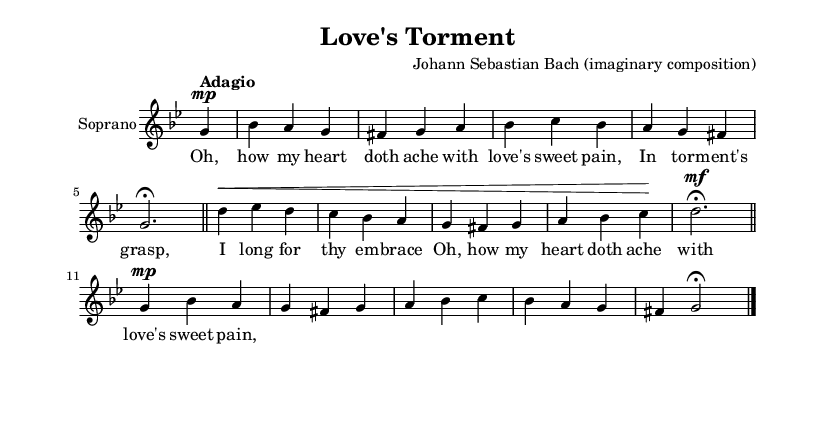What is the key signature of this music? The key signature is indicated at the beginning of the staff. The presence of two flats shows that it is in G minor.
Answer: G minor What is the time signature of this music? The time signature is shown next to the key signature. It is noted as 3/4, meaning there are three beats in a measure.
Answer: 3/4 What is the tempo marking of this piece? The tempo marking is written above the staff, directing the speed at which the piece should be played. It indicates "Adagio," which suggests a slow tempo.
Answer: Adagio How many measures are in the music? By counting the vertical lines in the score, which represent measures, we find there are five measures.
Answer: Five measures What dynamic marking appears in the first line? The dynamic marking for the first line is indicated as "mp," which stands for "mezzo-piano," meaning moderately soft.
Answer: Mezzo-piano How does the piece reflect Baroque characteristics, particularly in its emotional expression? The vocal line uses ornamentation and expressive dynamics, which are characteristic of Baroque opera arias. The lyrics convey deep emotions related to love, thus enhancing the dramatic intent typical in this genre.
Answer: Emotional expression What does the lyric “Oh, how my heart doth ache with love's sweet pain” convey about the relationship theme? The lyric expresses longing and emotional turmoil, characteristic of the complexities in romantic relationships, which is a common theme in Baroque operas.
Answer: Longing and emotional turmoil 